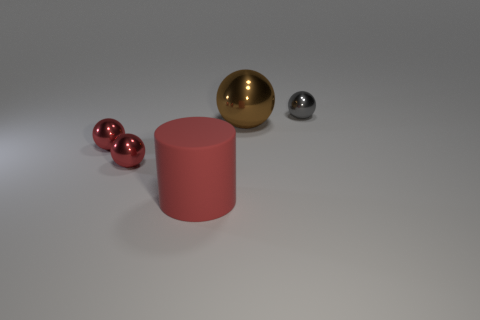Is there anything else that has the same material as the cylinder?
Your answer should be very brief. No. There is a big object that is in front of the big object that is behind the big object in front of the big sphere; what is its shape?
Provide a succinct answer. Cylinder. Are there fewer red things that are on the left side of the tiny gray metallic object than tiny spheres that are to the left of the matte object?
Ensure brevity in your answer.  No. The small metallic object on the right side of the big thing in front of the big brown thing is what shape?
Provide a short and direct response. Sphere. Is there any other thing that is the same color as the cylinder?
Your answer should be very brief. Yes. Do the matte thing and the large ball have the same color?
Ensure brevity in your answer.  No. What number of brown objects are metal objects or small matte things?
Ensure brevity in your answer.  1. Is the number of large rubber cylinders that are to the left of the red rubber thing less than the number of red metal objects?
Keep it short and to the point. Yes. There is a object that is behind the brown ball; what number of tiny red spheres are on the left side of it?
Your answer should be compact. 2. What number of other objects are the same size as the red cylinder?
Give a very brief answer. 1. 